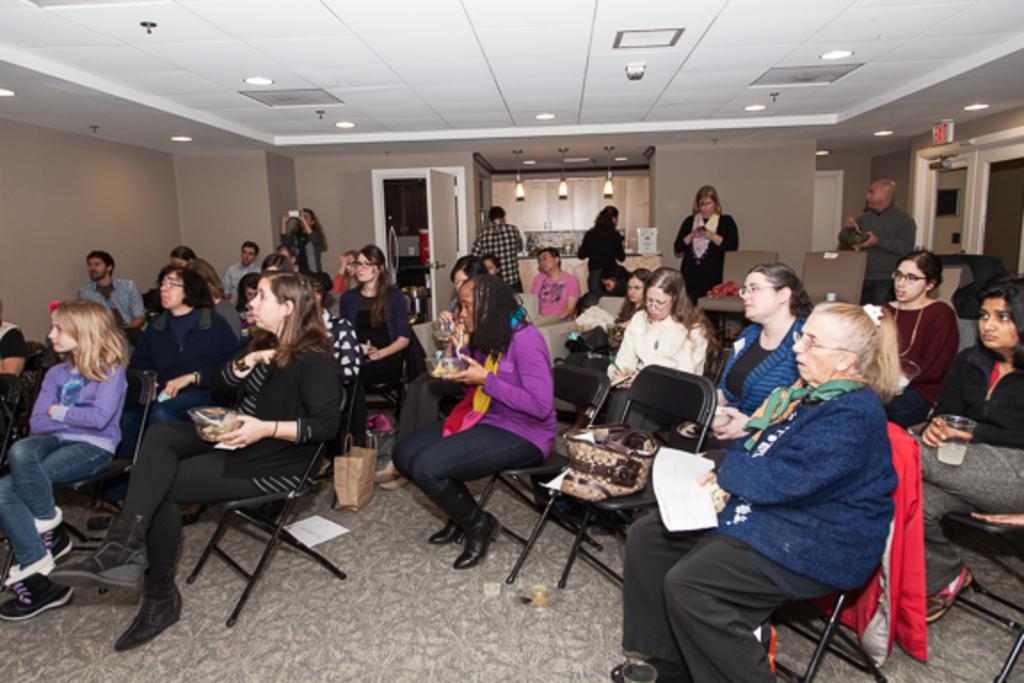Can you describe this image briefly? In this image we can see the people sitting on the chairs which are on the floor. We can also see the papers, bags, glasses, walls and also the lights. We can see the door. At the top we can see the ceiling with the ceiling lights. We can also see a few people standing. 